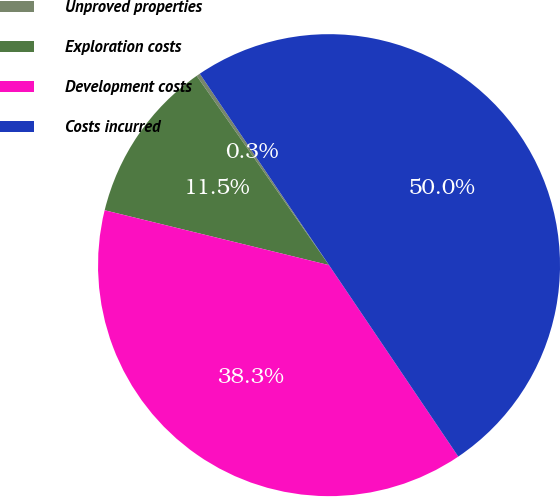Convert chart. <chart><loc_0><loc_0><loc_500><loc_500><pie_chart><fcel>Unproved properties<fcel>Exploration costs<fcel>Development costs<fcel>Costs incurred<nl><fcel>0.26%<fcel>11.47%<fcel>38.27%<fcel>50.0%<nl></chart> 